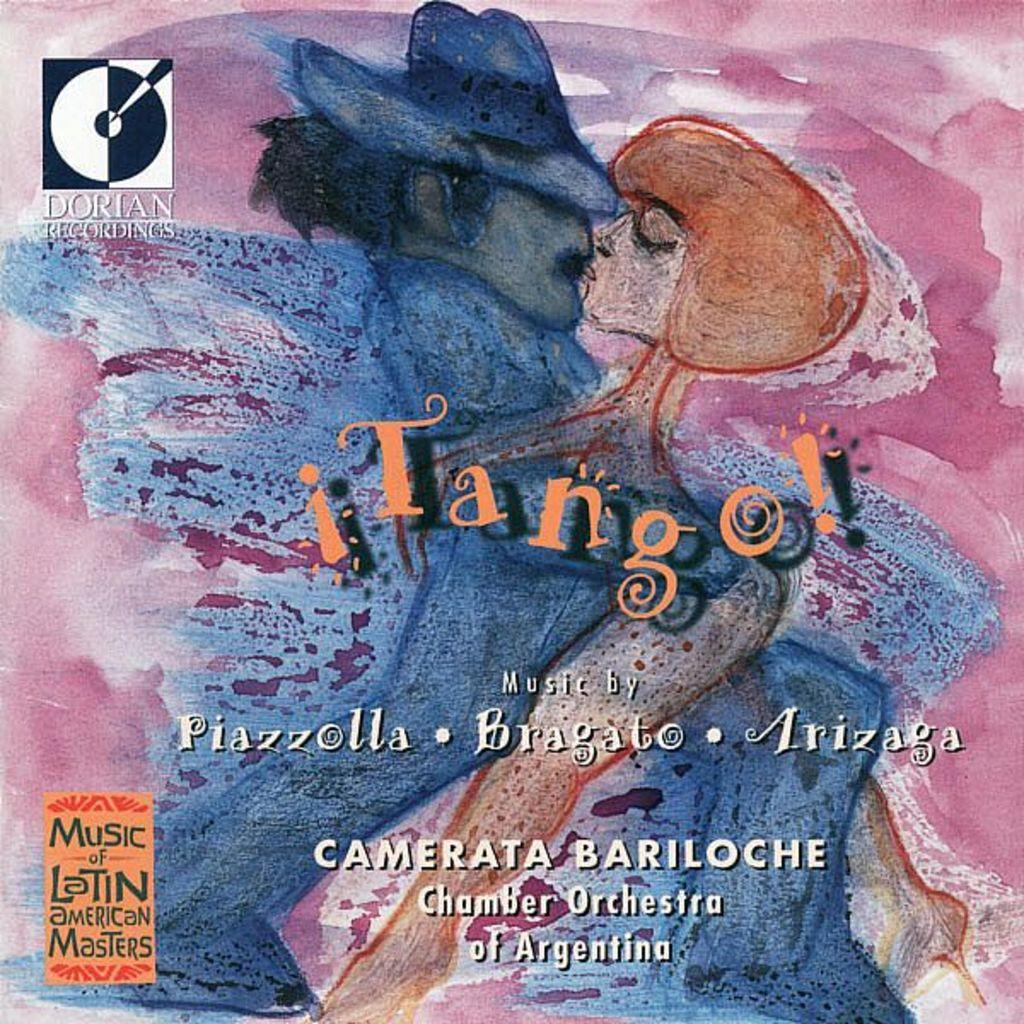<image>
Provide a brief description of the given image. A poster is for a performance by Camerata Bariloche and the Chamber Orchestra of Argentina. 